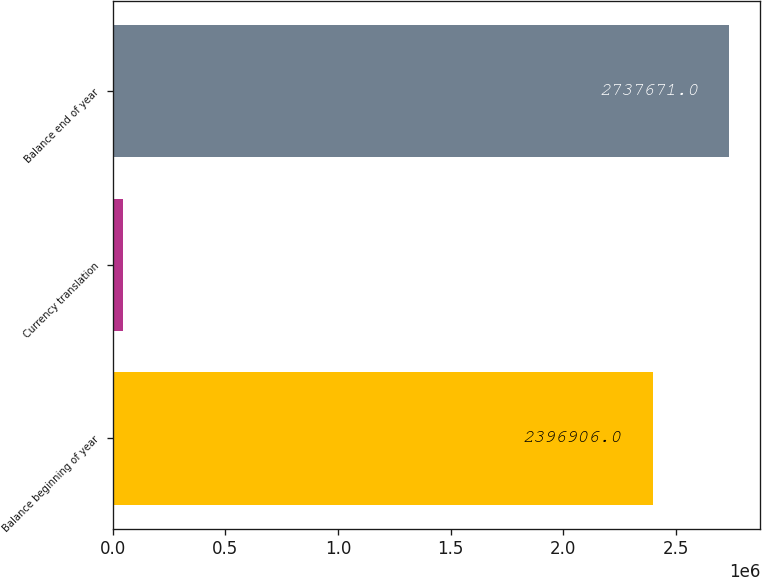<chart> <loc_0><loc_0><loc_500><loc_500><bar_chart><fcel>Balance beginning of year<fcel>Currency translation<fcel>Balance end of year<nl><fcel>2.39691e+06<fcel>46565<fcel>2.73767e+06<nl></chart> 